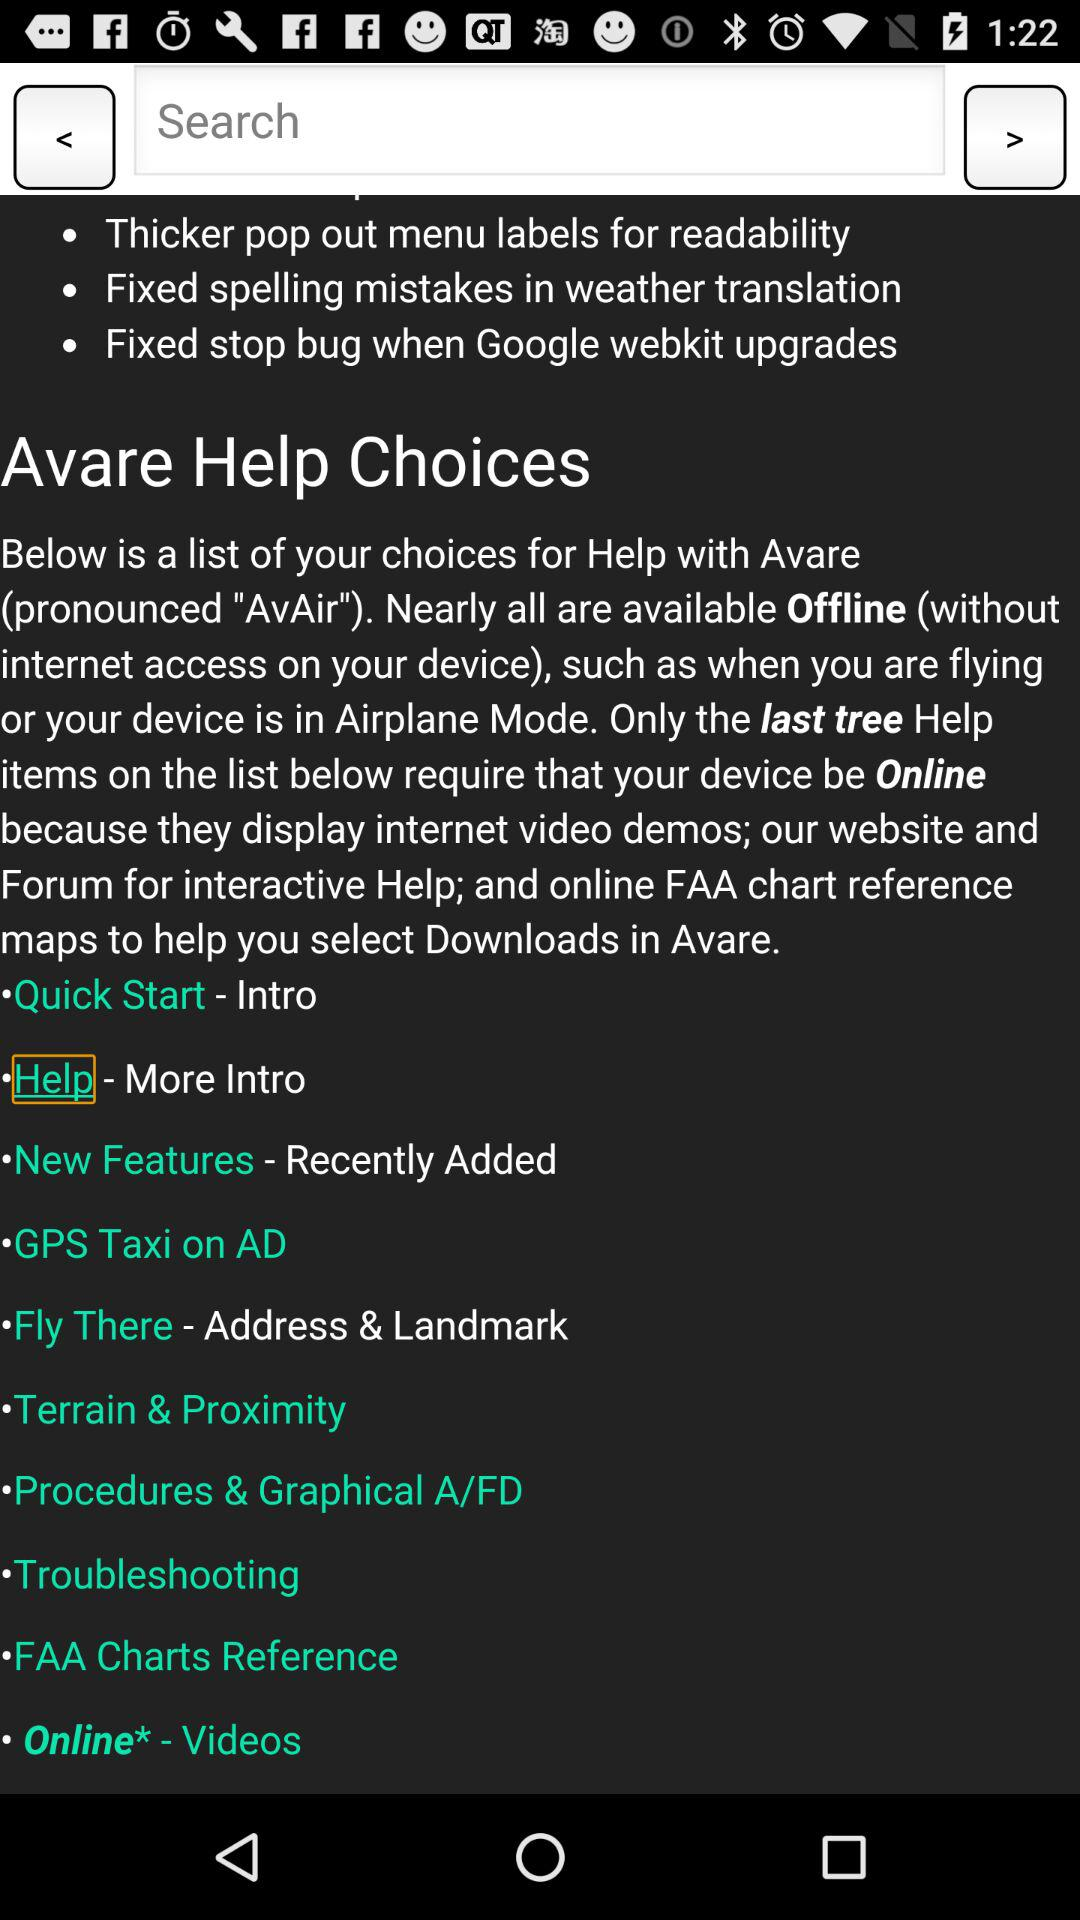How many help topics are there in total?
Answer the question using a single word or phrase. 10 